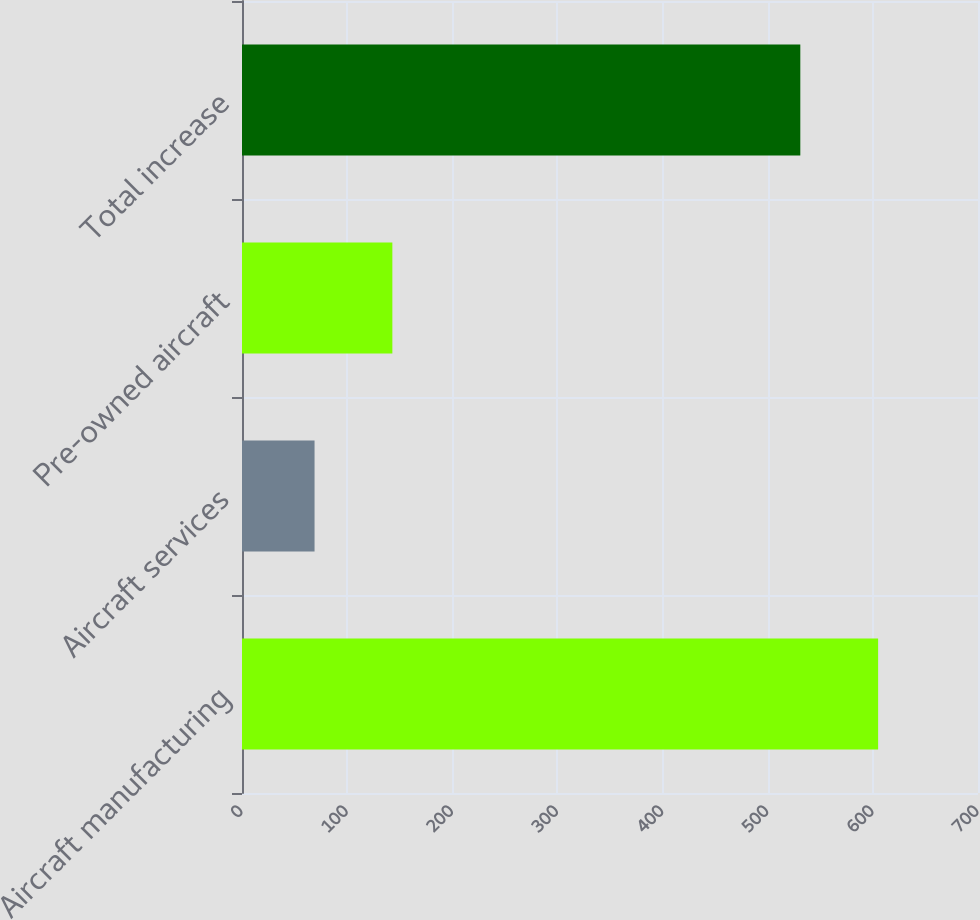<chart> <loc_0><loc_0><loc_500><loc_500><bar_chart><fcel>Aircraft manufacturing<fcel>Aircraft services<fcel>Pre-owned aircraft<fcel>Total increase<nl><fcel>605<fcel>69<fcel>143<fcel>531<nl></chart> 